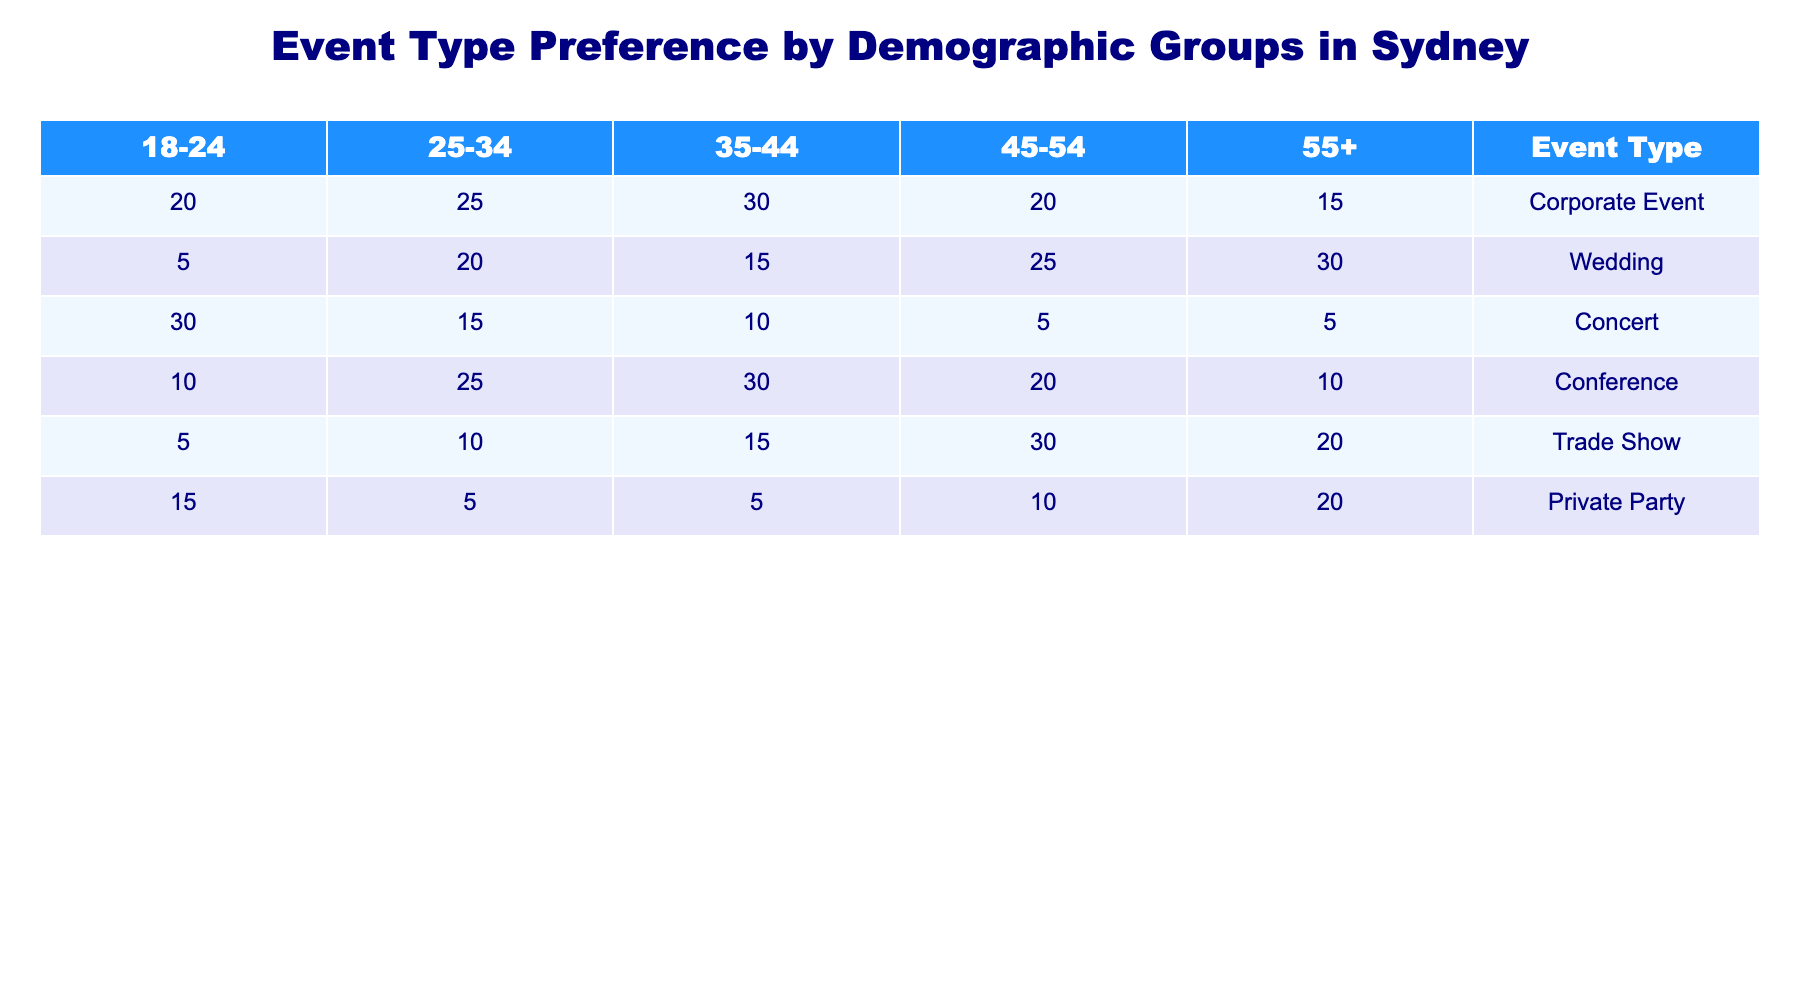What is the highest preference for Corporate Events among the demographic groups? The values for Corporate Events across the demographic groups are: 20 (18-24), 25 (25-34), 30 (35-44), 20 (45-54), and 15 (55+). The highest value is 30 from the 35-44 age group.
Answer: 30 Which demographic group has the lowest preference for Trade Shows? The values for Trade Shows are: 5 (18-24), 10 (25-34), 15 (35-44), 30 (45-54), and 20 (55+). The lowest value is 5 from the 18-24 age group.
Answer: 5 Is the preference for Weddings among the 55+ demographic group greater than that of the 25-34 demographic group? The preference for Weddings for the 55+ group is 30, while for the 25-34 group it is 20. Since 30 is greater than 20, the statement is true.
Answer: Yes What is the total preference for Private Parties across all demographic groups? The values for Private Parties are: 15 (18-24), 5 (25-34), 5 (35-44), 10 (45-54), and 20 (55+). Adding these values gives 15 + 5 + 5 + 10 + 20 = 55 for a total preference.
Answer: 55 Which event type has the highest total sum across all demographic groups? The sums for each event type are: Corporate Event (110), Wedding (100), Concert (75), Conference (105), Trade Show (70), and Private Party (55). The highest sum is for Corporate Events, which is 110.
Answer: Corporate Event What is the preference for Conferences for demographic groups aged 35-44 compared to those aged 45-54? The preference for Conferences is 30 for the 35-44 group and 20 for the 45-54 group. Therefore, the 35-44 group has a higher preference.
Answer: Higher for 35-44 What is the average preference for Concerts across all groups? The values for Concerts are: 30 (18-24), 15 (25-34), 10 (35-44), 5 (45-54), and 5 (55+). Summing these gives 30 + 15 + 10 + 5 + 5 = 65. Since there are 5 groups, the average is 65 / 5 = 13.
Answer: 13 Which demographic group shows the highest preference for Weddings overall? The values for Weddings are: 5 (18-24), 20 (25-34), 15 (35-44), 25 (45-54), and 30 (55+). The highest is 30 from the 55+ age group.
Answer: 30 